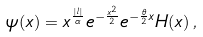<formula> <loc_0><loc_0><loc_500><loc_500>\psi ( x ) = x ^ { \frac { | l | } { \alpha } } e ^ { - \frac { x ^ { 2 } } { 2 } } e ^ { - \frac { \theta } { 2 } x } H ( x ) \, ,</formula> 